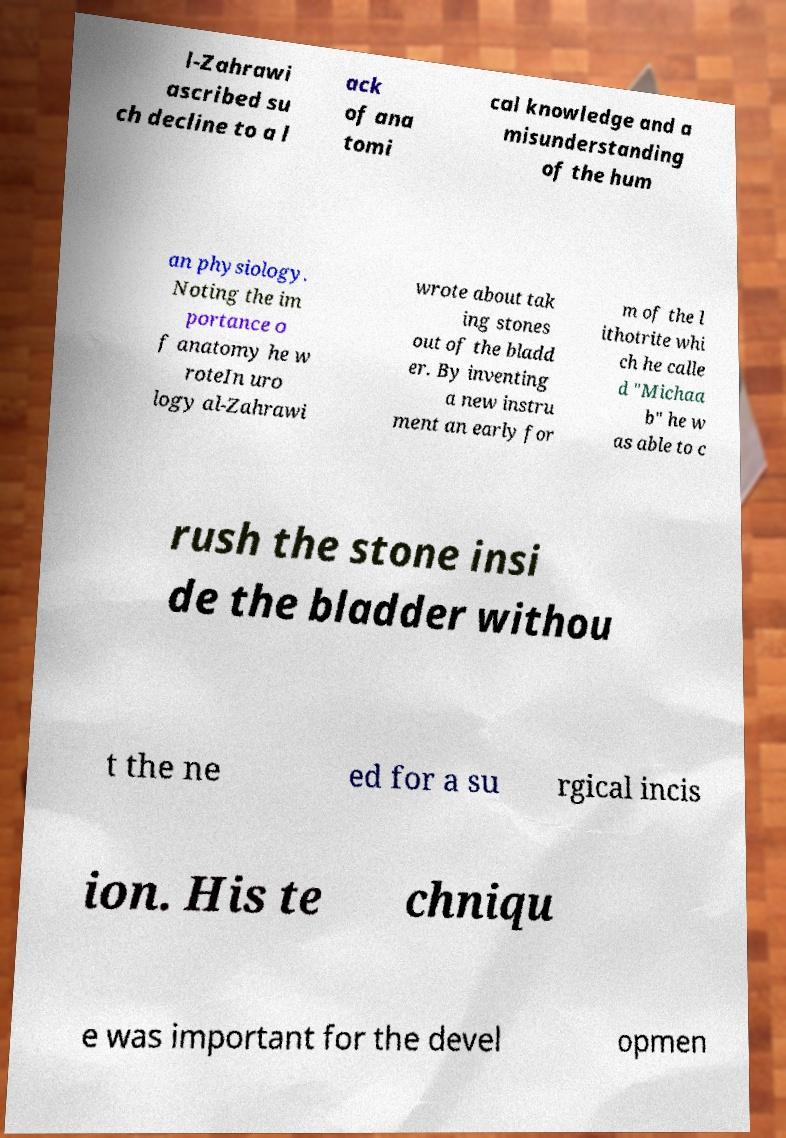What messages or text are displayed in this image? I need them in a readable, typed format. l-Zahrawi ascribed su ch decline to a l ack of ana tomi cal knowledge and a misunderstanding of the hum an physiology. Noting the im portance o f anatomy he w roteIn uro logy al-Zahrawi wrote about tak ing stones out of the bladd er. By inventing a new instru ment an early for m of the l ithotrite whi ch he calle d "Michaa b" he w as able to c rush the stone insi de the bladder withou t the ne ed for a su rgical incis ion. His te chniqu e was important for the devel opmen 